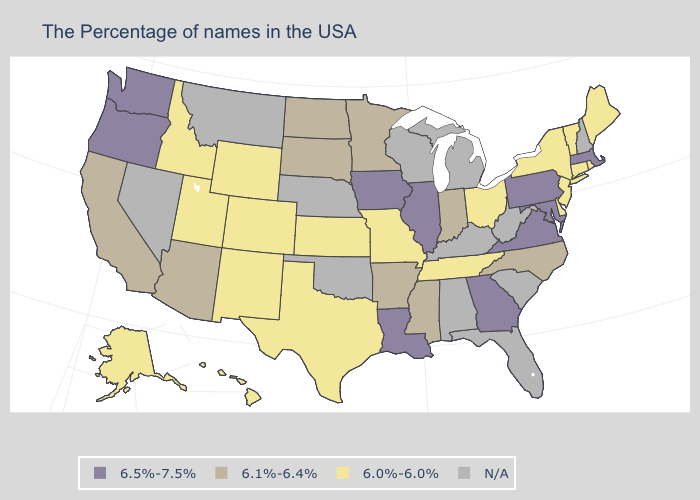Name the states that have a value in the range 6.0%-6.0%?
Give a very brief answer. Maine, Rhode Island, Vermont, Connecticut, New York, New Jersey, Delaware, Ohio, Tennessee, Missouri, Kansas, Texas, Wyoming, Colorado, New Mexico, Utah, Idaho, Alaska, Hawaii. Does the map have missing data?
Short answer required. Yes. What is the lowest value in the MidWest?
Keep it brief. 6.0%-6.0%. What is the value of New Mexico?
Concise answer only. 6.0%-6.0%. Does Wyoming have the lowest value in the USA?
Short answer required. Yes. What is the value of Kentucky?
Short answer required. N/A. Does California have the lowest value in the West?
Give a very brief answer. No. Among the states that border Massachusetts , which have the highest value?
Concise answer only. Rhode Island, Vermont, Connecticut, New York. Does Washington have the highest value in the West?
Write a very short answer. Yes. Does Vermont have the highest value in the Northeast?
Be succinct. No. What is the lowest value in the Northeast?
Write a very short answer. 6.0%-6.0%. What is the value of Colorado?
Keep it brief. 6.0%-6.0%. 